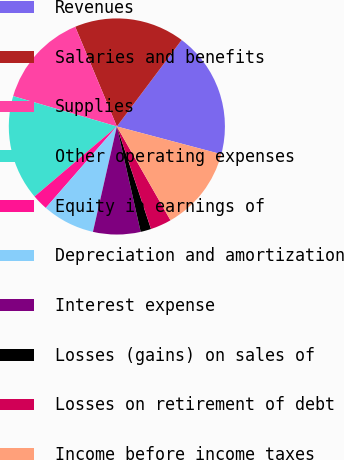Convert chart to OTSL. <chart><loc_0><loc_0><loc_500><loc_500><pie_chart><fcel>Revenues<fcel>Salaries and benefits<fcel>Supplies<fcel>Other operating expenses<fcel>Equity in earnings of<fcel>Depreciation and amortization<fcel>Interest expense<fcel>Losses (gains) on sales of<fcel>Losses on retirement of debt<fcel>Income before income taxes<nl><fcel>18.9%<fcel>16.53%<fcel>14.17%<fcel>15.75%<fcel>2.36%<fcel>7.87%<fcel>7.09%<fcel>1.58%<fcel>3.15%<fcel>12.6%<nl></chart> 